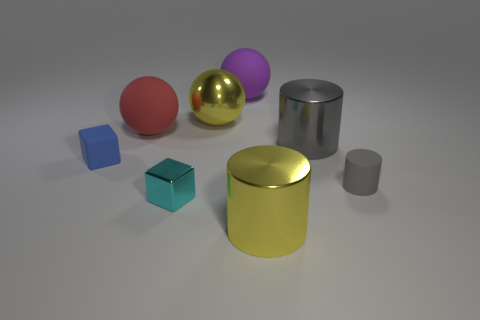Can you describe the sizes of the objects relative to each other? Certainly! In the image, we see objects varying in size. The red sphere and the golden sphere are roughly the same size, which appear to be the largest of the objects. The purple sphere is slightly smaller. The blue cube and the smaller gray cylinder are among the smallest objects present. The yellow cylinder is medium-sized and similar in height but larger in diameter compared to the gray cylinder. 